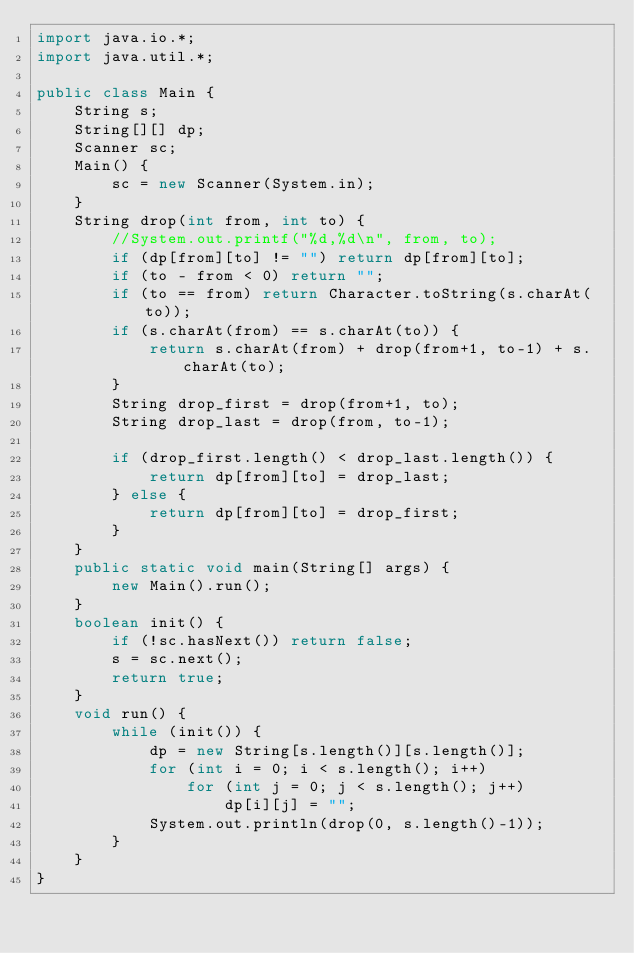<code> <loc_0><loc_0><loc_500><loc_500><_Java_>import java.io.*;
import java.util.*;

public class Main {
    String s;
    String[][] dp;
    Scanner sc;
    Main() {
        sc = new Scanner(System.in);
    }
    String drop(int from, int to) {
        //System.out.printf("%d,%d\n", from, to);
        if (dp[from][to] != "") return dp[from][to];
        if (to - from < 0) return "";
        if (to == from) return Character.toString(s.charAt(to));
        if (s.charAt(from) == s.charAt(to)) {
            return s.charAt(from) + drop(from+1, to-1) + s.charAt(to);
        }
        String drop_first = drop(from+1, to);
        String drop_last = drop(from, to-1);
    
        if (drop_first.length() < drop_last.length()) {
            return dp[from][to] = drop_last;
        } else {
            return dp[from][to] = drop_first;
        }
    }
    public static void main(String[] args) {
        new Main().run();
    }
    boolean init() {
        if (!sc.hasNext()) return false;
        s = sc.next();
        return true;
    }
    void run() {
        while (init()) {
            dp = new String[s.length()][s.length()];
            for (int i = 0; i < s.length(); i++) 
                for (int j = 0; j < s.length(); j++)
                    dp[i][j] = "";
            System.out.println(drop(0, s.length()-1));
        }
    }
}</code> 